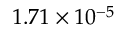<formula> <loc_0><loc_0><loc_500><loc_500>1 . 7 1 \times 1 0 ^ { - 5 }</formula> 